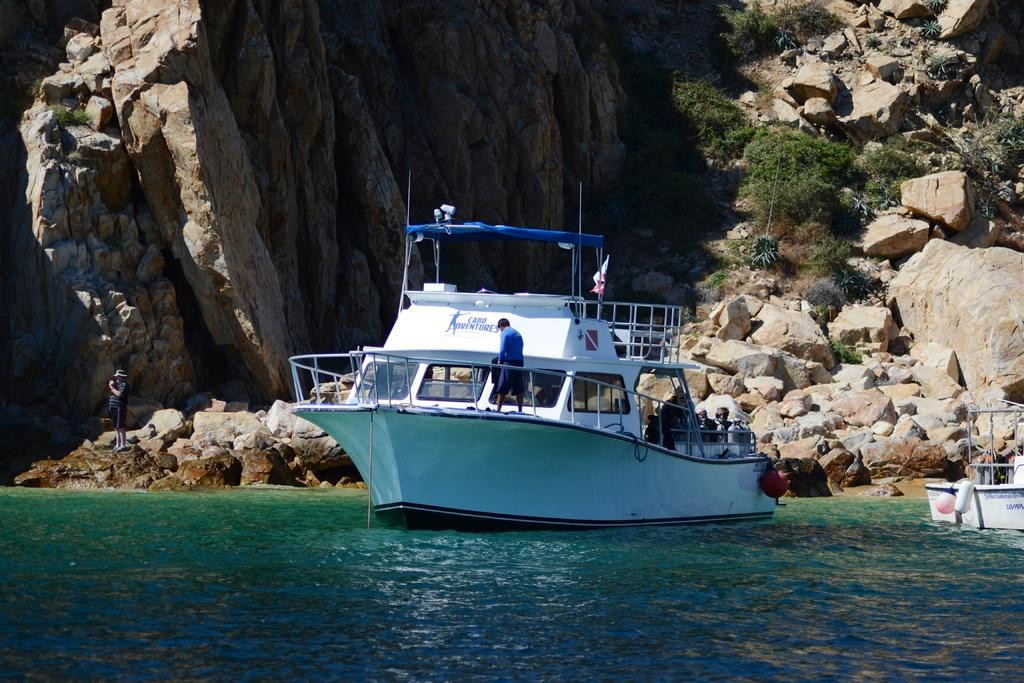<image>
Share a concise interpretation of the image provided. A ship with the company Cabo Adventures is sailing through the water. 